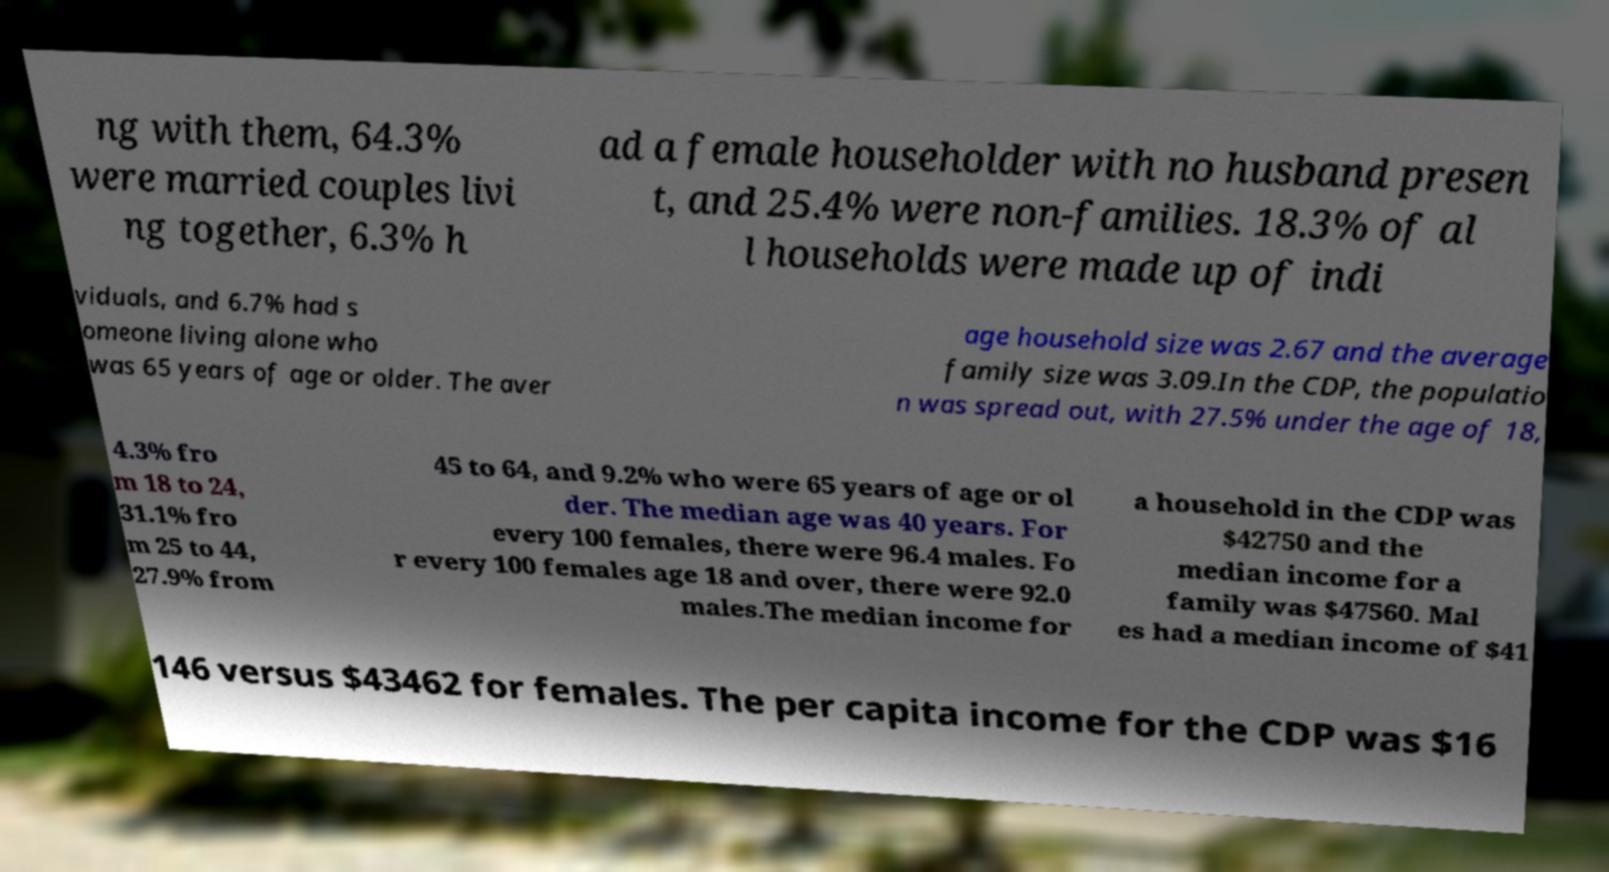Please identify and transcribe the text found in this image. ng with them, 64.3% were married couples livi ng together, 6.3% h ad a female householder with no husband presen t, and 25.4% were non-families. 18.3% of al l households were made up of indi viduals, and 6.7% had s omeone living alone who was 65 years of age or older. The aver age household size was 2.67 and the average family size was 3.09.In the CDP, the populatio n was spread out, with 27.5% under the age of 18, 4.3% fro m 18 to 24, 31.1% fro m 25 to 44, 27.9% from 45 to 64, and 9.2% who were 65 years of age or ol der. The median age was 40 years. For every 100 females, there were 96.4 males. Fo r every 100 females age 18 and over, there were 92.0 males.The median income for a household in the CDP was $42750 and the median income for a family was $47560. Mal es had a median income of $41 146 versus $43462 for females. The per capita income for the CDP was $16 